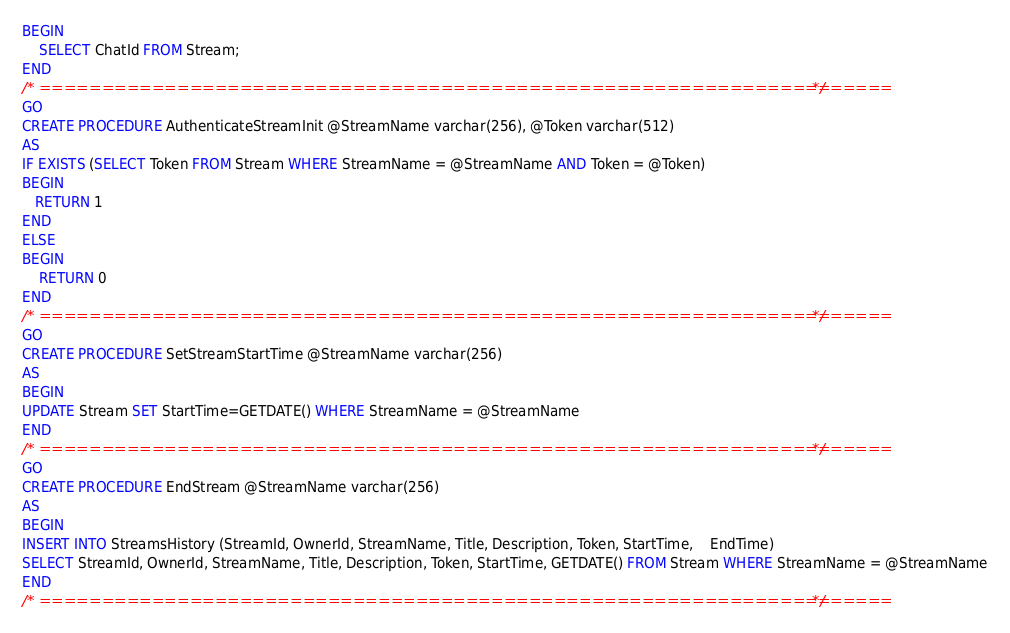<code> <loc_0><loc_0><loc_500><loc_500><_SQL_>BEGIN
	SELECT ChatId FROM Stream;
END
/* ==================================================================== */
GO
CREATE PROCEDURE AuthenticateStreamInit @StreamName varchar(256), @Token varchar(512)
AS
IF EXISTS (SELECT Token FROM Stream WHERE StreamName = @StreamName AND Token = @Token)
BEGIN
   RETURN 1 
END
ELSE
BEGIN
    RETURN 0
END
/* ==================================================================== */
GO
CREATE PROCEDURE SetStreamStartTime @StreamName varchar(256)
AS
BEGIN
UPDATE Stream SET StartTime=GETDATE() WHERE StreamName = @StreamName
END
/* ==================================================================== */
GO
CREATE PROCEDURE EndStream @StreamName varchar(256)
AS
BEGIN
INSERT INTO StreamsHistory (StreamId, OwnerId, StreamName, Title, Description, Token, StartTime,	EndTime)
SELECT StreamId, OwnerId, StreamName, Title, Description, Token, StartTime, GETDATE() FROM Stream WHERE StreamName = @StreamName
END
/* ==================================================================== */
</code> 